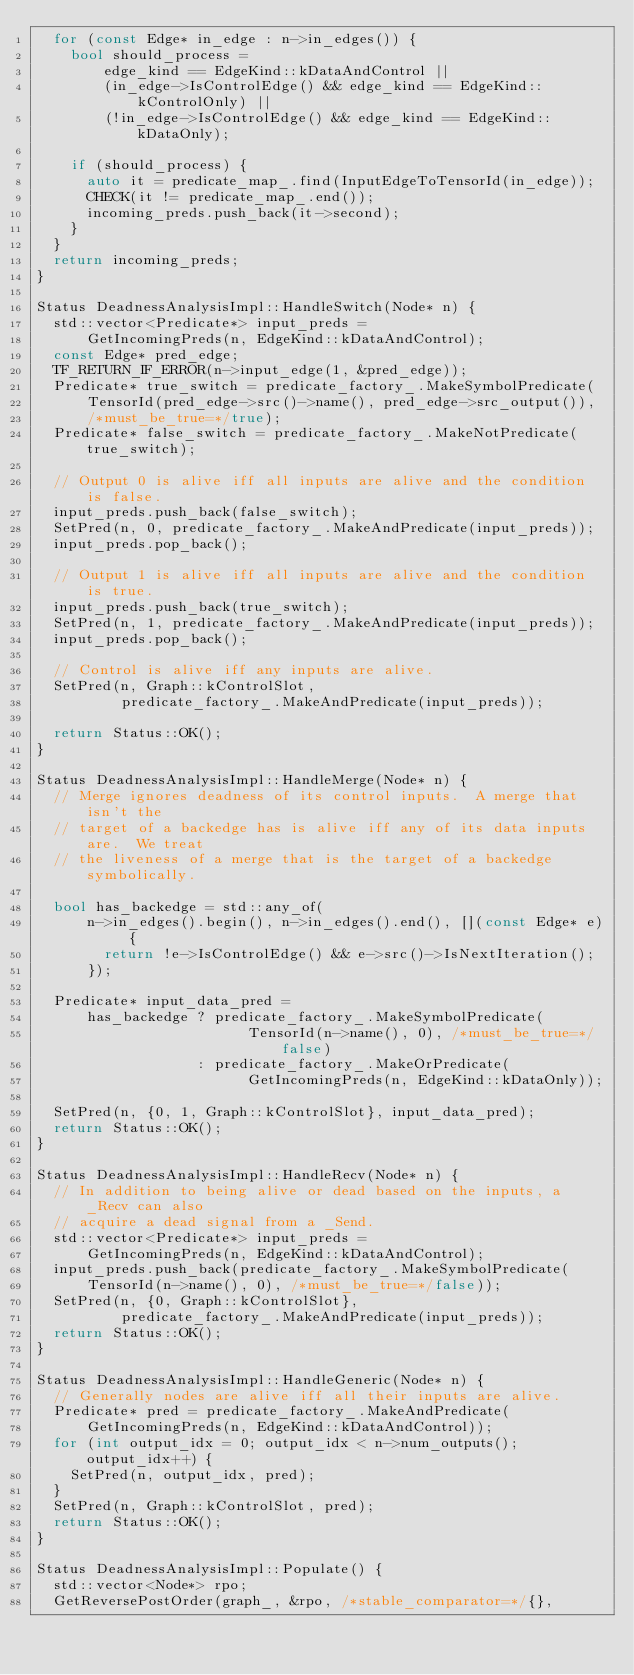<code> <loc_0><loc_0><loc_500><loc_500><_C++_>  for (const Edge* in_edge : n->in_edges()) {
    bool should_process =
        edge_kind == EdgeKind::kDataAndControl ||
        (in_edge->IsControlEdge() && edge_kind == EdgeKind::kControlOnly) ||
        (!in_edge->IsControlEdge() && edge_kind == EdgeKind::kDataOnly);

    if (should_process) {
      auto it = predicate_map_.find(InputEdgeToTensorId(in_edge));
      CHECK(it != predicate_map_.end());
      incoming_preds.push_back(it->second);
    }
  }
  return incoming_preds;
}

Status DeadnessAnalysisImpl::HandleSwitch(Node* n) {
  std::vector<Predicate*> input_preds =
      GetIncomingPreds(n, EdgeKind::kDataAndControl);
  const Edge* pred_edge;
  TF_RETURN_IF_ERROR(n->input_edge(1, &pred_edge));
  Predicate* true_switch = predicate_factory_.MakeSymbolPredicate(
      TensorId(pred_edge->src()->name(), pred_edge->src_output()),
      /*must_be_true=*/true);
  Predicate* false_switch = predicate_factory_.MakeNotPredicate(true_switch);

  // Output 0 is alive iff all inputs are alive and the condition is false.
  input_preds.push_back(false_switch);
  SetPred(n, 0, predicate_factory_.MakeAndPredicate(input_preds));
  input_preds.pop_back();

  // Output 1 is alive iff all inputs are alive and the condition is true.
  input_preds.push_back(true_switch);
  SetPred(n, 1, predicate_factory_.MakeAndPredicate(input_preds));
  input_preds.pop_back();

  // Control is alive iff any inputs are alive.
  SetPred(n, Graph::kControlSlot,
          predicate_factory_.MakeAndPredicate(input_preds));

  return Status::OK();
}

Status DeadnessAnalysisImpl::HandleMerge(Node* n) {
  // Merge ignores deadness of its control inputs.  A merge that isn't the
  // target of a backedge has is alive iff any of its data inputs are.  We treat
  // the liveness of a merge that is the target of a backedge symbolically.

  bool has_backedge = std::any_of(
      n->in_edges().begin(), n->in_edges().end(), [](const Edge* e) {
        return !e->IsControlEdge() && e->src()->IsNextIteration();
      });

  Predicate* input_data_pred =
      has_backedge ? predicate_factory_.MakeSymbolPredicate(
                         TensorId(n->name(), 0), /*must_be_true=*/false)
                   : predicate_factory_.MakeOrPredicate(
                         GetIncomingPreds(n, EdgeKind::kDataOnly));

  SetPred(n, {0, 1, Graph::kControlSlot}, input_data_pred);
  return Status::OK();
}

Status DeadnessAnalysisImpl::HandleRecv(Node* n) {
  // In addition to being alive or dead based on the inputs, a _Recv can also
  // acquire a dead signal from a _Send.
  std::vector<Predicate*> input_preds =
      GetIncomingPreds(n, EdgeKind::kDataAndControl);
  input_preds.push_back(predicate_factory_.MakeSymbolPredicate(
      TensorId(n->name(), 0), /*must_be_true=*/false));
  SetPred(n, {0, Graph::kControlSlot},
          predicate_factory_.MakeAndPredicate(input_preds));
  return Status::OK();
}

Status DeadnessAnalysisImpl::HandleGeneric(Node* n) {
  // Generally nodes are alive iff all their inputs are alive.
  Predicate* pred = predicate_factory_.MakeAndPredicate(
      GetIncomingPreds(n, EdgeKind::kDataAndControl));
  for (int output_idx = 0; output_idx < n->num_outputs(); output_idx++) {
    SetPred(n, output_idx, pred);
  }
  SetPred(n, Graph::kControlSlot, pred);
  return Status::OK();
}

Status DeadnessAnalysisImpl::Populate() {
  std::vector<Node*> rpo;
  GetReversePostOrder(graph_, &rpo, /*stable_comparator=*/{},</code> 